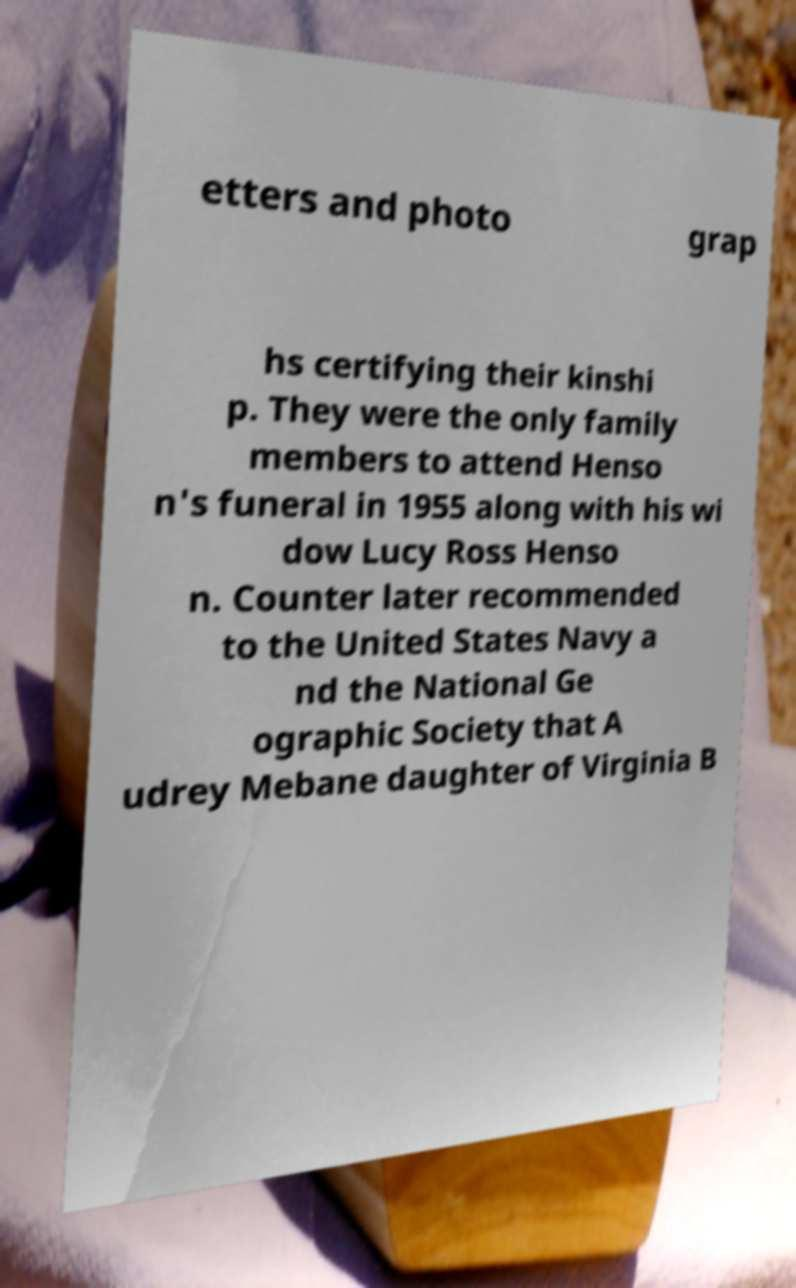Can you accurately transcribe the text from the provided image for me? etters and photo grap hs certifying their kinshi p. They were the only family members to attend Henso n's funeral in 1955 along with his wi dow Lucy Ross Henso n. Counter later recommended to the United States Navy a nd the National Ge ographic Society that A udrey Mebane daughter of Virginia B 